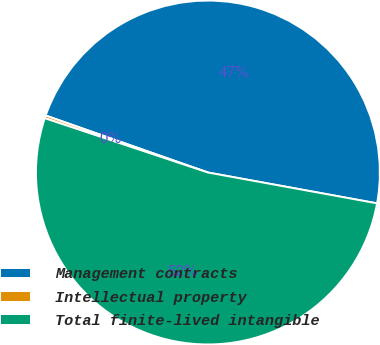Convert chart to OTSL. <chart><loc_0><loc_0><loc_500><loc_500><pie_chart><fcel>Management contracts<fcel>Intellectual property<fcel>Total finite-lived intangible<nl><fcel>47.5%<fcel>0.26%<fcel>52.25%<nl></chart> 